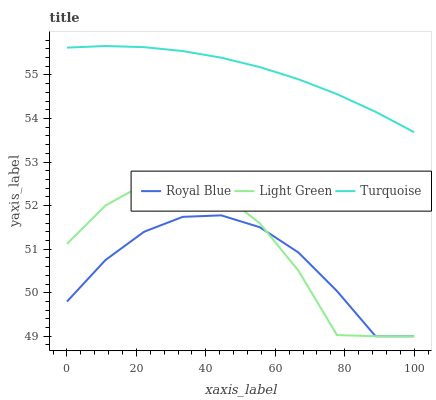Does Royal Blue have the minimum area under the curve?
Answer yes or no. Yes. Does Turquoise have the maximum area under the curve?
Answer yes or no. Yes. Does Light Green have the minimum area under the curve?
Answer yes or no. No. Does Light Green have the maximum area under the curve?
Answer yes or no. No. Is Turquoise the smoothest?
Answer yes or no. Yes. Is Light Green the roughest?
Answer yes or no. Yes. Is Light Green the smoothest?
Answer yes or no. No. Is Turquoise the roughest?
Answer yes or no. No. Does Royal Blue have the lowest value?
Answer yes or no. Yes. Does Turquoise have the lowest value?
Answer yes or no. No. Does Turquoise have the highest value?
Answer yes or no. Yes. Does Light Green have the highest value?
Answer yes or no. No. Is Royal Blue less than Turquoise?
Answer yes or no. Yes. Is Turquoise greater than Royal Blue?
Answer yes or no. Yes. Does Light Green intersect Royal Blue?
Answer yes or no. Yes. Is Light Green less than Royal Blue?
Answer yes or no. No. Is Light Green greater than Royal Blue?
Answer yes or no. No. Does Royal Blue intersect Turquoise?
Answer yes or no. No. 